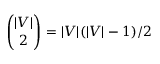Convert formula to latex. <formula><loc_0><loc_0><loc_500><loc_500>{ \binom { | V | } { 2 } } = | V | ( | V | - 1 ) / 2</formula> 